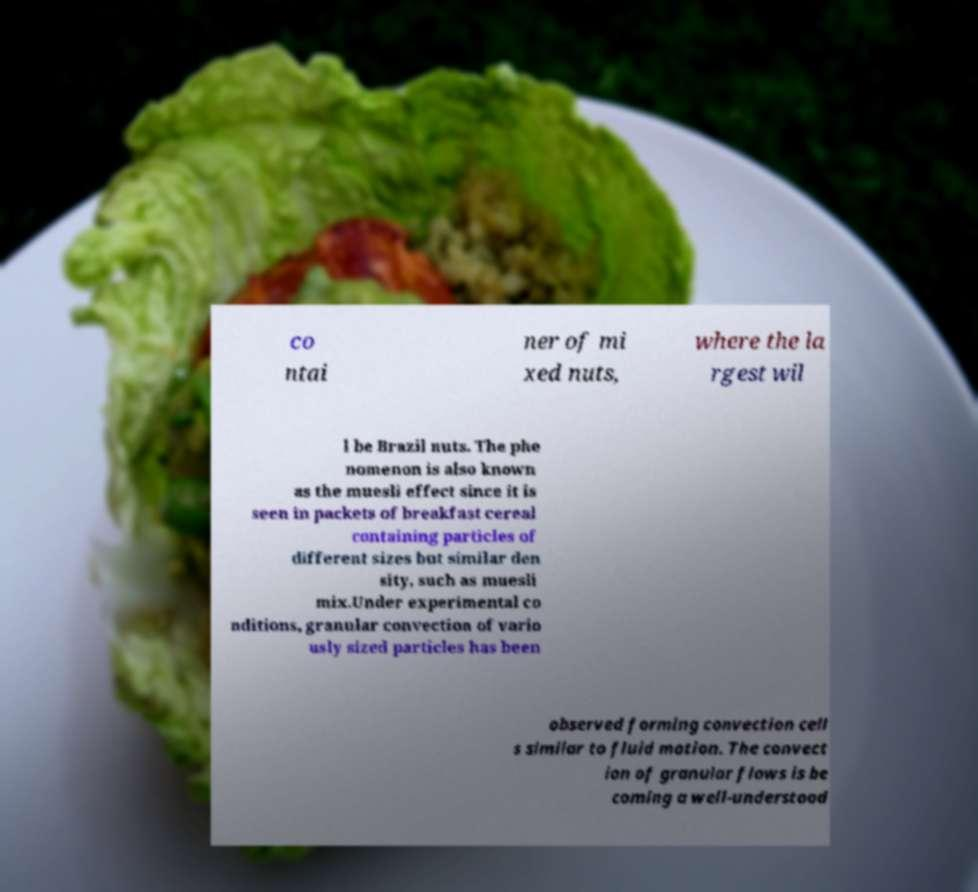Can you read and provide the text displayed in the image?This photo seems to have some interesting text. Can you extract and type it out for me? co ntai ner of mi xed nuts, where the la rgest wil l be Brazil nuts. The phe nomenon is also known as the muesli effect since it is seen in packets of breakfast cereal containing particles of different sizes but similar den sity, such as muesli mix.Under experimental co nditions, granular convection of vario usly sized particles has been observed forming convection cell s similar to fluid motion. The convect ion of granular flows is be coming a well-understood 